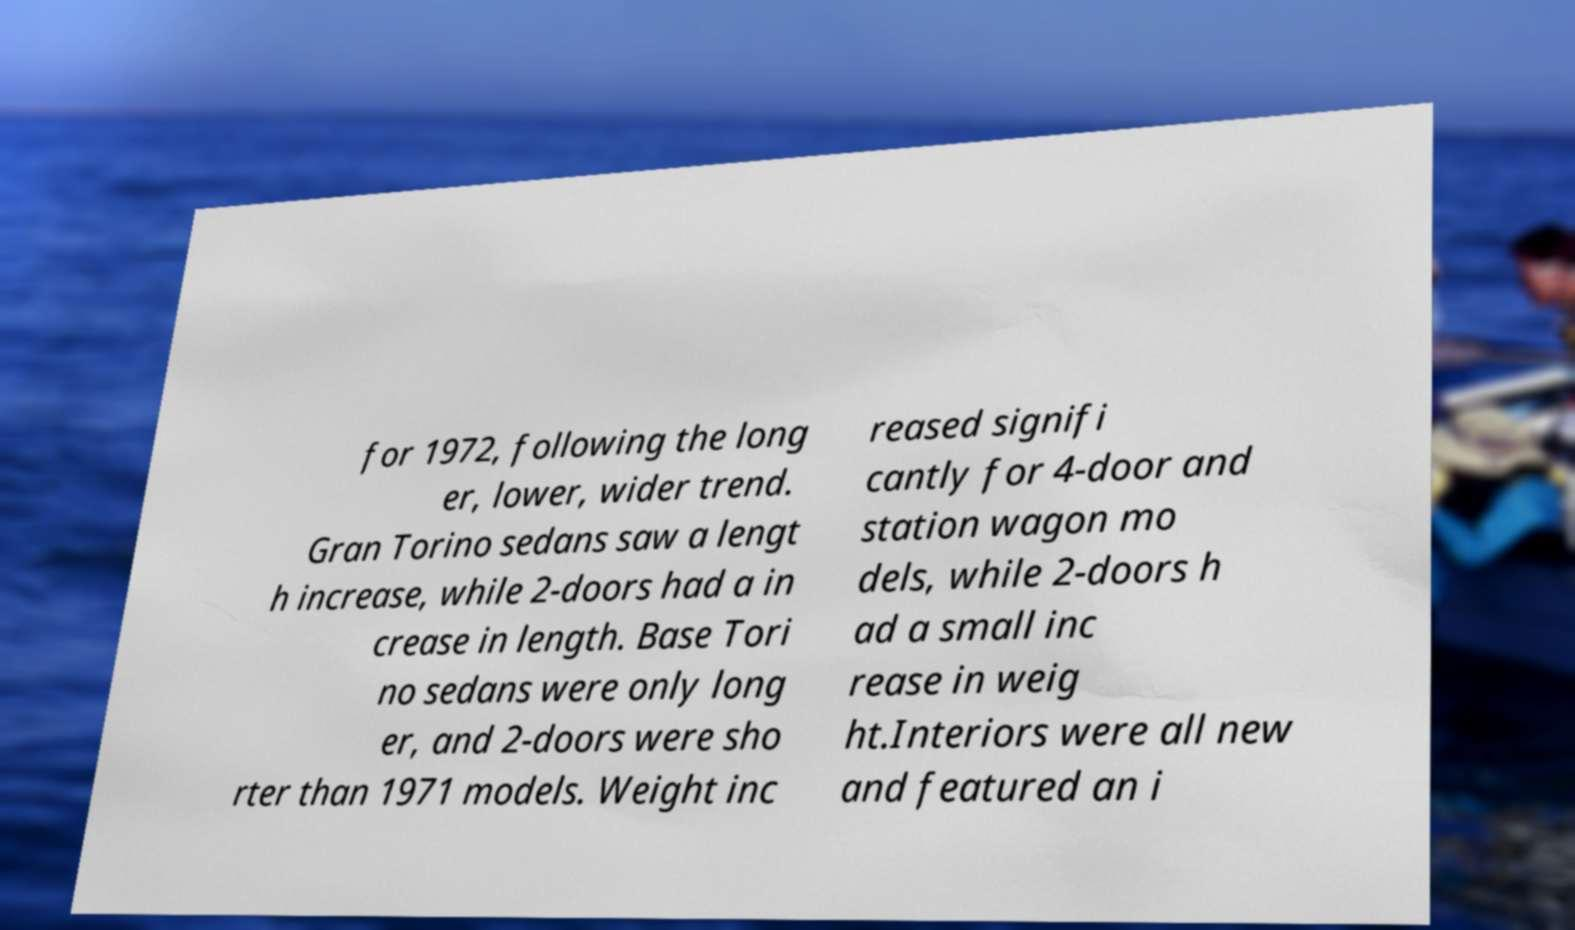For documentation purposes, I need the text within this image transcribed. Could you provide that? for 1972, following the long er, lower, wider trend. Gran Torino sedans saw a lengt h increase, while 2-doors had a in crease in length. Base Tori no sedans were only long er, and 2-doors were sho rter than 1971 models. Weight inc reased signifi cantly for 4-door and station wagon mo dels, while 2-doors h ad a small inc rease in weig ht.Interiors were all new and featured an i 